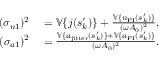<formula> <loc_0><loc_0><loc_500><loc_500>\begin{array} { r l } { ( \sigma _ { n 1 } ) ^ { 2 } } & = \mathbb { V } \{ j ( s _ { k } ^ { \prime } ) \} + \frac { \mathbb { V } \{ n _ { P I } ( s _ { k } ^ { \prime } ) \} } { ( \omega A _ { 0 } ) ^ { 2 } } , } \\ { ( \sigma _ { a 1 } ) ^ { 2 } } & = \frac { \mathbb { V } \{ a _ { j i t t e r } ( s _ { k } ^ { \prime } ) \} + \mathbb { V } \{ a _ { P I } ( s _ { k } ^ { \prime } ) \} } { ( \omega A _ { 0 } ) ^ { 2 } } . } \end{array}</formula> 